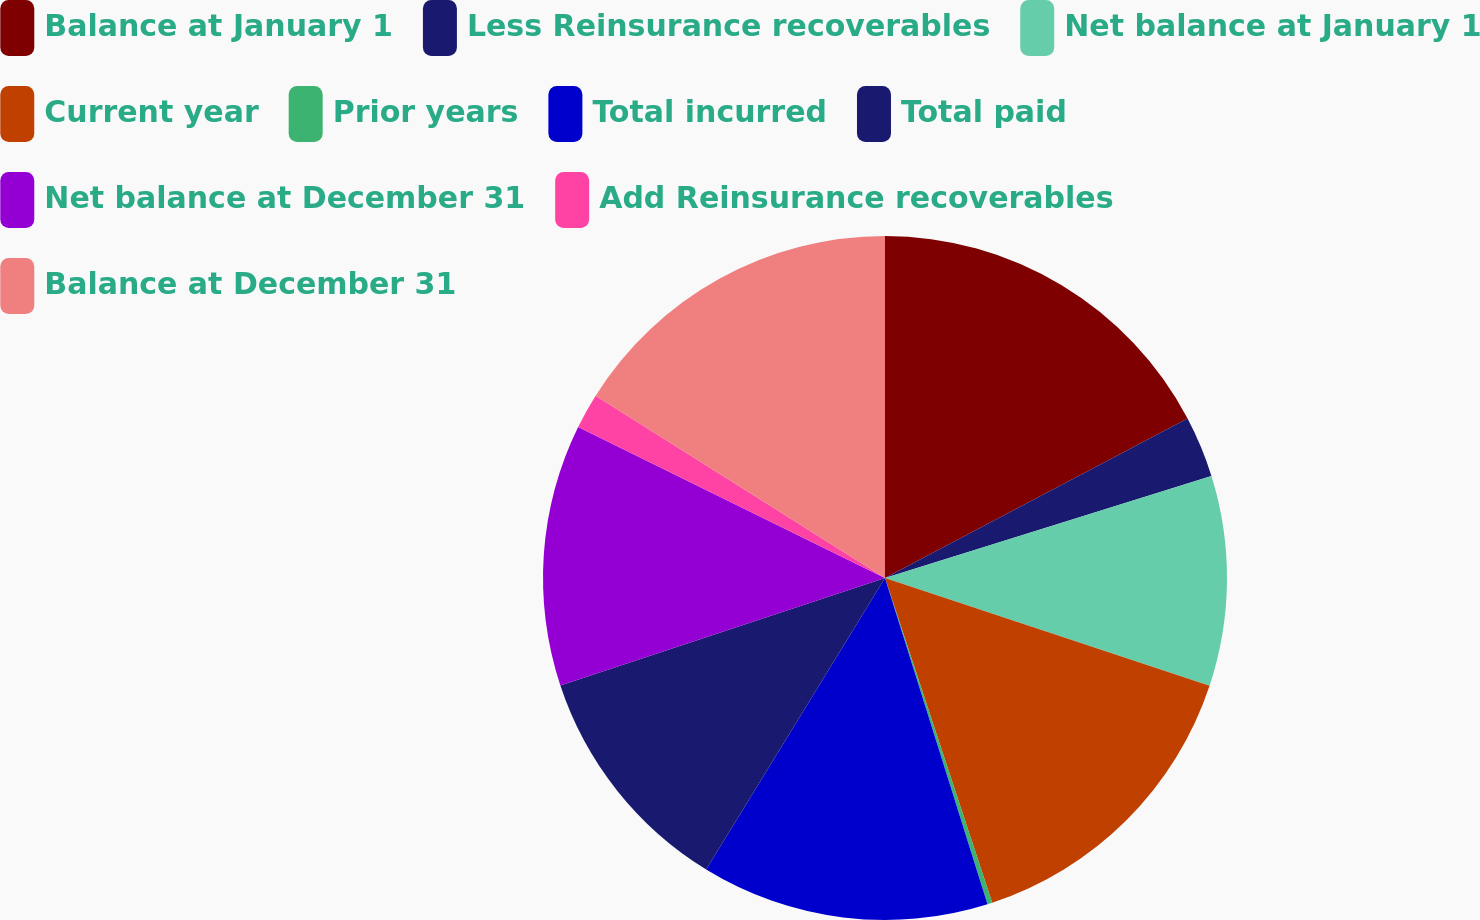<chart> <loc_0><loc_0><loc_500><loc_500><pie_chart><fcel>Balance at January 1<fcel>Less Reinsurance recoverables<fcel>Net balance at January 1<fcel>Current year<fcel>Prior years<fcel>Total incurred<fcel>Total paid<fcel>Net balance at December 31<fcel>Add Reinsurance recoverables<fcel>Balance at December 31<nl><fcel>17.28%<fcel>2.9%<fcel>9.92%<fcel>14.82%<fcel>0.23%<fcel>13.6%<fcel>11.15%<fcel>12.37%<fcel>1.67%<fcel>16.05%<nl></chart> 